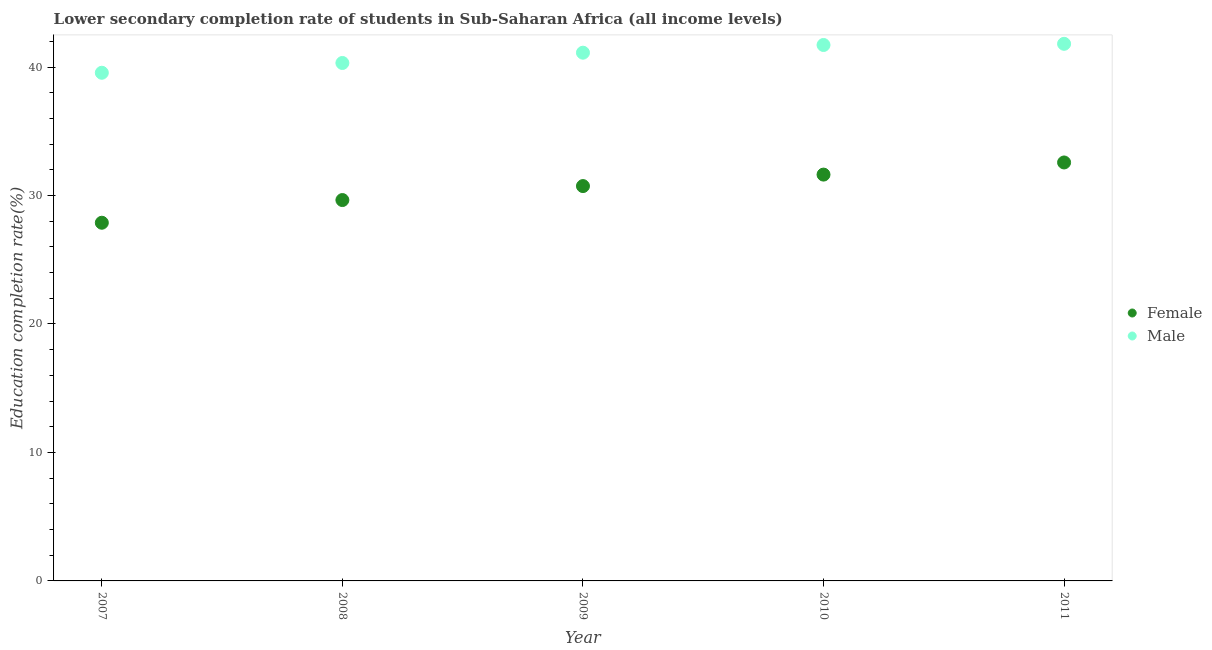Is the number of dotlines equal to the number of legend labels?
Your response must be concise. Yes. What is the education completion rate of male students in 2007?
Your answer should be compact. 39.55. Across all years, what is the maximum education completion rate of female students?
Provide a succinct answer. 32.57. Across all years, what is the minimum education completion rate of female students?
Make the answer very short. 27.88. In which year was the education completion rate of female students minimum?
Your response must be concise. 2007. What is the total education completion rate of male students in the graph?
Offer a terse response. 204.51. What is the difference between the education completion rate of female students in 2010 and that in 2011?
Offer a very short reply. -0.94. What is the difference between the education completion rate of female students in 2007 and the education completion rate of male students in 2010?
Provide a succinct answer. -13.84. What is the average education completion rate of male students per year?
Ensure brevity in your answer.  40.9. In the year 2009, what is the difference between the education completion rate of female students and education completion rate of male students?
Offer a terse response. -10.38. What is the ratio of the education completion rate of female students in 2007 to that in 2010?
Your answer should be compact. 0.88. What is the difference between the highest and the second highest education completion rate of female students?
Keep it short and to the point. 0.94. What is the difference between the highest and the lowest education completion rate of female students?
Ensure brevity in your answer.  4.69. In how many years, is the education completion rate of female students greater than the average education completion rate of female students taken over all years?
Ensure brevity in your answer.  3. Is the sum of the education completion rate of male students in 2008 and 2009 greater than the maximum education completion rate of female students across all years?
Provide a succinct answer. Yes. Does the education completion rate of female students monotonically increase over the years?
Your answer should be compact. Yes. How many years are there in the graph?
Provide a succinct answer. 5. Are the values on the major ticks of Y-axis written in scientific E-notation?
Offer a very short reply. No. Does the graph contain any zero values?
Provide a succinct answer. No. Does the graph contain grids?
Your answer should be very brief. No. Where does the legend appear in the graph?
Ensure brevity in your answer.  Center right. How are the legend labels stacked?
Provide a succinct answer. Vertical. What is the title of the graph?
Ensure brevity in your answer.  Lower secondary completion rate of students in Sub-Saharan Africa (all income levels). Does "Female population" appear as one of the legend labels in the graph?
Give a very brief answer. No. What is the label or title of the X-axis?
Ensure brevity in your answer.  Year. What is the label or title of the Y-axis?
Offer a very short reply. Education completion rate(%). What is the Education completion rate(%) of Female in 2007?
Your answer should be very brief. 27.88. What is the Education completion rate(%) of Male in 2007?
Offer a very short reply. 39.55. What is the Education completion rate(%) in Female in 2008?
Provide a succinct answer. 29.65. What is the Education completion rate(%) of Male in 2008?
Offer a very short reply. 40.32. What is the Education completion rate(%) in Female in 2009?
Give a very brief answer. 30.73. What is the Education completion rate(%) in Male in 2009?
Offer a terse response. 41.12. What is the Education completion rate(%) of Female in 2010?
Give a very brief answer. 31.63. What is the Education completion rate(%) in Male in 2010?
Offer a terse response. 41.72. What is the Education completion rate(%) of Female in 2011?
Keep it short and to the point. 32.57. What is the Education completion rate(%) of Male in 2011?
Ensure brevity in your answer.  41.81. Across all years, what is the maximum Education completion rate(%) in Female?
Give a very brief answer. 32.57. Across all years, what is the maximum Education completion rate(%) in Male?
Offer a terse response. 41.81. Across all years, what is the minimum Education completion rate(%) in Female?
Give a very brief answer. 27.88. Across all years, what is the minimum Education completion rate(%) in Male?
Provide a short and direct response. 39.55. What is the total Education completion rate(%) of Female in the graph?
Make the answer very short. 152.46. What is the total Education completion rate(%) in Male in the graph?
Provide a short and direct response. 204.51. What is the difference between the Education completion rate(%) of Female in 2007 and that in 2008?
Make the answer very short. -1.77. What is the difference between the Education completion rate(%) in Male in 2007 and that in 2008?
Keep it short and to the point. -0.76. What is the difference between the Education completion rate(%) in Female in 2007 and that in 2009?
Give a very brief answer. -2.85. What is the difference between the Education completion rate(%) of Male in 2007 and that in 2009?
Give a very brief answer. -1.56. What is the difference between the Education completion rate(%) in Female in 2007 and that in 2010?
Ensure brevity in your answer.  -3.75. What is the difference between the Education completion rate(%) in Male in 2007 and that in 2010?
Offer a very short reply. -2.16. What is the difference between the Education completion rate(%) of Female in 2007 and that in 2011?
Your answer should be compact. -4.69. What is the difference between the Education completion rate(%) in Male in 2007 and that in 2011?
Keep it short and to the point. -2.25. What is the difference between the Education completion rate(%) of Female in 2008 and that in 2009?
Your answer should be very brief. -1.09. What is the difference between the Education completion rate(%) in Male in 2008 and that in 2009?
Provide a succinct answer. -0.8. What is the difference between the Education completion rate(%) of Female in 2008 and that in 2010?
Offer a terse response. -1.98. What is the difference between the Education completion rate(%) of Male in 2008 and that in 2010?
Give a very brief answer. -1.4. What is the difference between the Education completion rate(%) in Female in 2008 and that in 2011?
Make the answer very short. -2.93. What is the difference between the Education completion rate(%) of Male in 2008 and that in 2011?
Provide a short and direct response. -1.49. What is the difference between the Education completion rate(%) in Female in 2009 and that in 2010?
Ensure brevity in your answer.  -0.89. What is the difference between the Education completion rate(%) of Male in 2009 and that in 2010?
Give a very brief answer. -0.6. What is the difference between the Education completion rate(%) of Female in 2009 and that in 2011?
Your answer should be very brief. -1.84. What is the difference between the Education completion rate(%) of Male in 2009 and that in 2011?
Your response must be concise. -0.69. What is the difference between the Education completion rate(%) of Female in 2010 and that in 2011?
Your answer should be compact. -0.94. What is the difference between the Education completion rate(%) of Male in 2010 and that in 2011?
Your answer should be very brief. -0.09. What is the difference between the Education completion rate(%) of Female in 2007 and the Education completion rate(%) of Male in 2008?
Offer a terse response. -12.44. What is the difference between the Education completion rate(%) in Female in 2007 and the Education completion rate(%) in Male in 2009?
Your answer should be compact. -13.24. What is the difference between the Education completion rate(%) of Female in 2007 and the Education completion rate(%) of Male in 2010?
Provide a succinct answer. -13.84. What is the difference between the Education completion rate(%) in Female in 2007 and the Education completion rate(%) in Male in 2011?
Keep it short and to the point. -13.93. What is the difference between the Education completion rate(%) in Female in 2008 and the Education completion rate(%) in Male in 2009?
Provide a succinct answer. -11.47. What is the difference between the Education completion rate(%) of Female in 2008 and the Education completion rate(%) of Male in 2010?
Keep it short and to the point. -12.07. What is the difference between the Education completion rate(%) in Female in 2008 and the Education completion rate(%) in Male in 2011?
Your answer should be very brief. -12.16. What is the difference between the Education completion rate(%) in Female in 2009 and the Education completion rate(%) in Male in 2010?
Provide a succinct answer. -10.98. What is the difference between the Education completion rate(%) of Female in 2009 and the Education completion rate(%) of Male in 2011?
Make the answer very short. -11.07. What is the difference between the Education completion rate(%) in Female in 2010 and the Education completion rate(%) in Male in 2011?
Provide a succinct answer. -10.18. What is the average Education completion rate(%) in Female per year?
Your response must be concise. 30.49. What is the average Education completion rate(%) of Male per year?
Keep it short and to the point. 40.9. In the year 2007, what is the difference between the Education completion rate(%) of Female and Education completion rate(%) of Male?
Your answer should be compact. -11.67. In the year 2008, what is the difference between the Education completion rate(%) in Female and Education completion rate(%) in Male?
Provide a short and direct response. -10.67. In the year 2009, what is the difference between the Education completion rate(%) of Female and Education completion rate(%) of Male?
Offer a very short reply. -10.38. In the year 2010, what is the difference between the Education completion rate(%) of Female and Education completion rate(%) of Male?
Keep it short and to the point. -10.09. In the year 2011, what is the difference between the Education completion rate(%) of Female and Education completion rate(%) of Male?
Provide a short and direct response. -9.24. What is the ratio of the Education completion rate(%) of Female in 2007 to that in 2008?
Keep it short and to the point. 0.94. What is the ratio of the Education completion rate(%) in Male in 2007 to that in 2008?
Provide a succinct answer. 0.98. What is the ratio of the Education completion rate(%) in Female in 2007 to that in 2009?
Ensure brevity in your answer.  0.91. What is the ratio of the Education completion rate(%) in Female in 2007 to that in 2010?
Your answer should be very brief. 0.88. What is the ratio of the Education completion rate(%) in Male in 2007 to that in 2010?
Ensure brevity in your answer.  0.95. What is the ratio of the Education completion rate(%) in Female in 2007 to that in 2011?
Keep it short and to the point. 0.86. What is the ratio of the Education completion rate(%) of Male in 2007 to that in 2011?
Ensure brevity in your answer.  0.95. What is the ratio of the Education completion rate(%) in Female in 2008 to that in 2009?
Your answer should be very brief. 0.96. What is the ratio of the Education completion rate(%) in Male in 2008 to that in 2009?
Make the answer very short. 0.98. What is the ratio of the Education completion rate(%) in Female in 2008 to that in 2010?
Offer a very short reply. 0.94. What is the ratio of the Education completion rate(%) in Male in 2008 to that in 2010?
Give a very brief answer. 0.97. What is the ratio of the Education completion rate(%) in Female in 2008 to that in 2011?
Give a very brief answer. 0.91. What is the ratio of the Education completion rate(%) of Male in 2008 to that in 2011?
Offer a terse response. 0.96. What is the ratio of the Education completion rate(%) of Female in 2009 to that in 2010?
Provide a short and direct response. 0.97. What is the ratio of the Education completion rate(%) of Male in 2009 to that in 2010?
Your answer should be compact. 0.99. What is the ratio of the Education completion rate(%) in Female in 2009 to that in 2011?
Provide a succinct answer. 0.94. What is the ratio of the Education completion rate(%) of Male in 2009 to that in 2011?
Your answer should be compact. 0.98. What is the ratio of the Education completion rate(%) in Male in 2010 to that in 2011?
Keep it short and to the point. 1. What is the difference between the highest and the second highest Education completion rate(%) of Female?
Offer a terse response. 0.94. What is the difference between the highest and the second highest Education completion rate(%) in Male?
Provide a short and direct response. 0.09. What is the difference between the highest and the lowest Education completion rate(%) of Female?
Your answer should be very brief. 4.69. What is the difference between the highest and the lowest Education completion rate(%) of Male?
Keep it short and to the point. 2.25. 